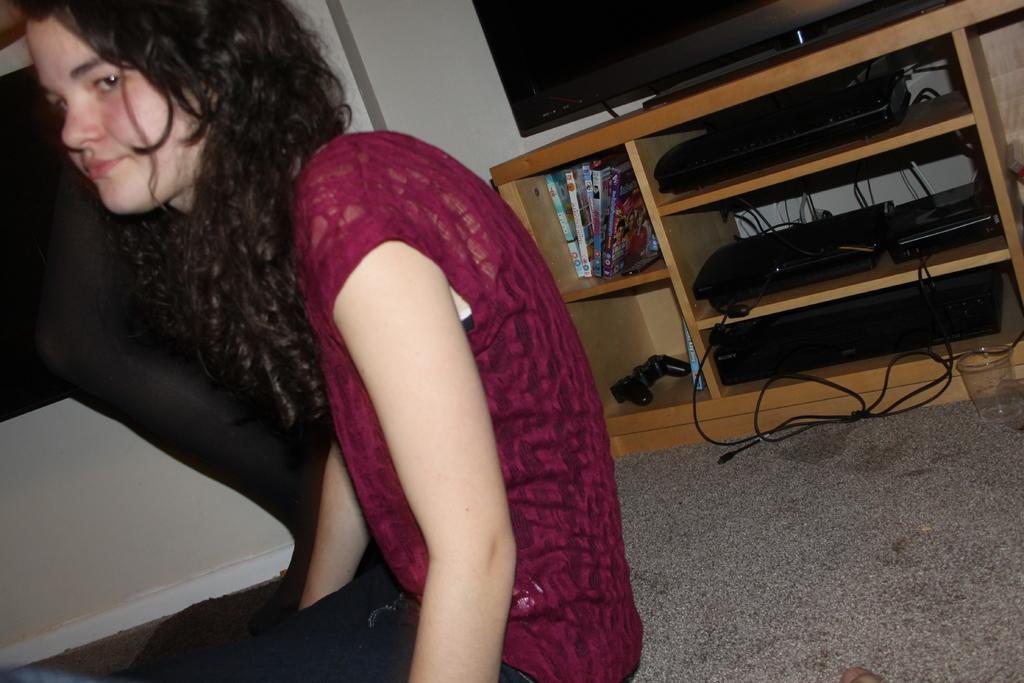Please provide a concise description of this image. In this image, we can see a person wearing clothes. There is a TV at the top of the image. There are some books and electronic gadgets in the rack. There is a glass on the right side of the image. 